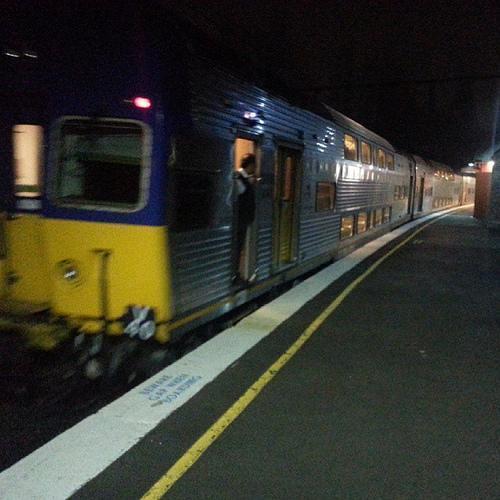How many people are visible in this photo?
Give a very brief answer. 1. How many headlights are lit on the front of the train?
Give a very brief answer. 1. 